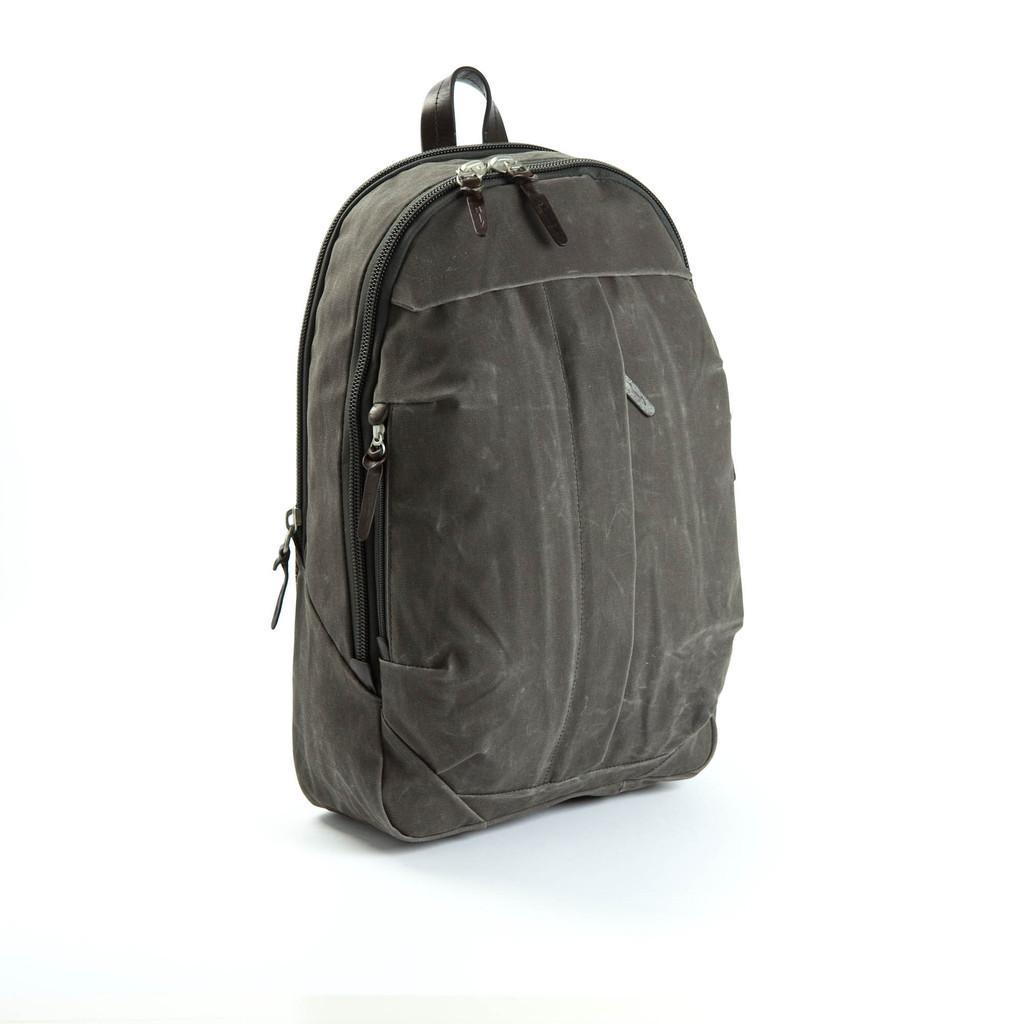Could you give a brief overview of what you see in this image? This picture shows a backpack which is black in colour 